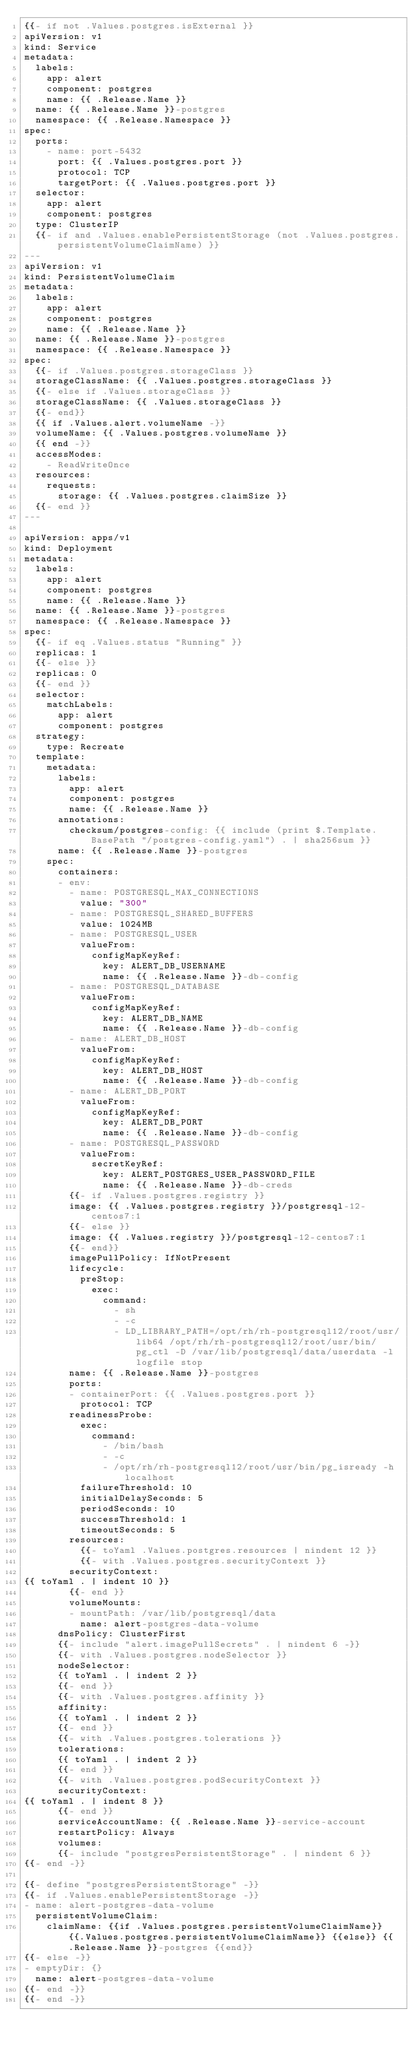<code> <loc_0><loc_0><loc_500><loc_500><_YAML_>{{- if not .Values.postgres.isExternal }}
apiVersion: v1
kind: Service
metadata:
  labels:
    app: alert
    component: postgres
    name: {{ .Release.Name }}
  name: {{ .Release.Name }}-postgres
  namespace: {{ .Release.Namespace }}
spec:
  ports:
    - name: port-5432
      port: {{ .Values.postgres.port }}
      protocol: TCP
      targetPort: {{ .Values.postgres.port }}
  selector:
    app: alert
    component: postgres
  type: ClusterIP
  {{- if and .Values.enablePersistentStorage (not .Values.postgres.persistentVolumeClaimName) }}
---
apiVersion: v1
kind: PersistentVolumeClaim
metadata:
  labels:
    app: alert
    component: postgres
    name: {{ .Release.Name }}
  name: {{ .Release.Name }}-postgres
  namespace: {{ .Release.Namespace }}
spec:
  {{- if .Values.postgres.storageClass }}
  storageClassName: {{ .Values.postgres.storageClass }}
  {{- else if .Values.storageClass }}
  storageClassName: {{ .Values.storageClass }}
  {{- end}}
  {{ if .Values.alert.volumeName -}}
  volumeName: {{ .Values.postgres.volumeName }}
  {{ end -}}
  accessModes:
    - ReadWriteOnce
  resources:
    requests:
      storage: {{ .Values.postgres.claimSize }}
  {{- end }}
---

apiVersion: apps/v1
kind: Deployment
metadata:
  labels:
    app: alert
    component: postgres
    name: {{ .Release.Name }}
  name: {{ .Release.Name }}-postgres
  namespace: {{ .Release.Namespace }}
spec:
  {{- if eq .Values.status "Running" }}
  replicas: 1
  {{- else }}
  replicas: 0
  {{- end }}
  selector:
    matchLabels:
      app: alert
      component: postgres
  strategy:
    type: Recreate
  template:
    metadata:
      labels:
        app: alert
        component: postgres
        name: {{ .Release.Name }}
      annotations:
        checksum/postgres-config: {{ include (print $.Template.BasePath "/postgres-config.yaml") . | sha256sum }}
      name: {{ .Release.Name }}-postgres
    spec:
      containers:
      - env:
        - name: POSTGRESQL_MAX_CONNECTIONS
          value: "300"
        - name: POSTGRESQL_SHARED_BUFFERS
          value: 1024MB
        - name: POSTGRESQL_USER
          valueFrom:
            configMapKeyRef:
              key: ALERT_DB_USERNAME
              name: {{ .Release.Name }}-db-config
        - name: POSTGRESQL_DATABASE
          valueFrom:
            configMapKeyRef:
              key: ALERT_DB_NAME
              name: {{ .Release.Name }}-db-config
        - name: ALERT_DB_HOST
          valueFrom:
            configMapKeyRef:
              key: ALERT_DB_HOST
              name: {{ .Release.Name }}-db-config
        - name: ALERT_DB_PORT
          valueFrom:
            configMapKeyRef:
              key: ALERT_DB_PORT
              name: {{ .Release.Name }}-db-config
        - name: POSTGRESQL_PASSWORD
          valueFrom:
            secretKeyRef:
              key: ALERT_POSTGRES_USER_PASSWORD_FILE
              name: {{ .Release.Name }}-db-creds
        {{- if .Values.postgres.registry }}
        image: {{ .Values.postgres.registry }}/postgresql-12-centos7:1
        {{- else }}
        image: {{ .Values.registry }}/postgresql-12-centos7:1
        {{- end}}
        imagePullPolicy: IfNotPresent
        lifecycle:
          preStop:
            exec:
              command:
                - sh
                - -c
                - LD_LIBRARY_PATH=/opt/rh/rh-postgresql12/root/usr/lib64 /opt/rh/rh-postgresql12/root/usr/bin/pg_ctl -D /var/lib/postgresql/data/userdata -l logfile stop
        name: {{ .Release.Name }}-postgres
        ports:
        - containerPort: {{ .Values.postgres.port }}
          protocol: TCP
        readinessProbe:
          exec:
            command:
              - /bin/bash
              - -c
              - /opt/rh/rh-postgresql12/root/usr/bin/pg_isready -h localhost
          failureThreshold: 10
          initialDelaySeconds: 5
          periodSeconds: 10
          successThreshold: 1
          timeoutSeconds: 5
        resources:
          {{- toYaml .Values.postgres.resources | nindent 12 }}
          {{- with .Values.postgres.securityContext }}
        securityContext:
{{ toYaml . | indent 10 }}
        {{- end }}
        volumeMounts:
        - mountPath: /var/lib/postgresql/data
          name: alert-postgres-data-volume
      dnsPolicy: ClusterFirst
      {{- include "alert.imagePullSecrets" . | nindent 6 -}}
      {{- with .Values.postgres.nodeSelector }}
      nodeSelector:
      {{ toYaml . | indent 2 }}
      {{- end }}
      {{- with .Values.postgres.affinity }}
      affinity:
      {{ toYaml . | indent 2 }}
      {{- end }}
      {{- with .Values.postgres.tolerations }}
      tolerations:
      {{ toYaml . | indent 2 }}
      {{- end }}
      {{- with .Values.postgres.podSecurityContext }}
      securityContext:
{{ toYaml . | indent 8 }}
      {{- end }}
      serviceAccountName: {{ .Release.Name }}-service-account
      restartPolicy: Always
      volumes:
      {{- include "postgresPersistentStorage" . | nindent 6 }}
{{- end -}}

{{- define "postgresPersistentStorage" -}}
{{- if .Values.enablePersistentStorage -}}
- name: alert-postgres-data-volume
  persistentVolumeClaim:
    claimName: {{if .Values.postgres.persistentVolumeClaimName}} {{.Values.postgres.persistentVolumeClaimName}} {{else}} {{ .Release.Name }}-postgres {{end}}
{{- else -}}
- emptyDir: {}
  name: alert-postgres-data-volume
{{- end -}}
{{- end -}}
</code> 